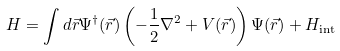<formula> <loc_0><loc_0><loc_500><loc_500>H = \int d \vec { r } \Psi ^ { \dagger } ( \vec { r } ) \left ( - \frac { 1 } { 2 } \nabla ^ { 2 } + V ( \vec { r } ) \right ) \Psi ( \vec { r } ) + H _ { \text {int} }</formula> 